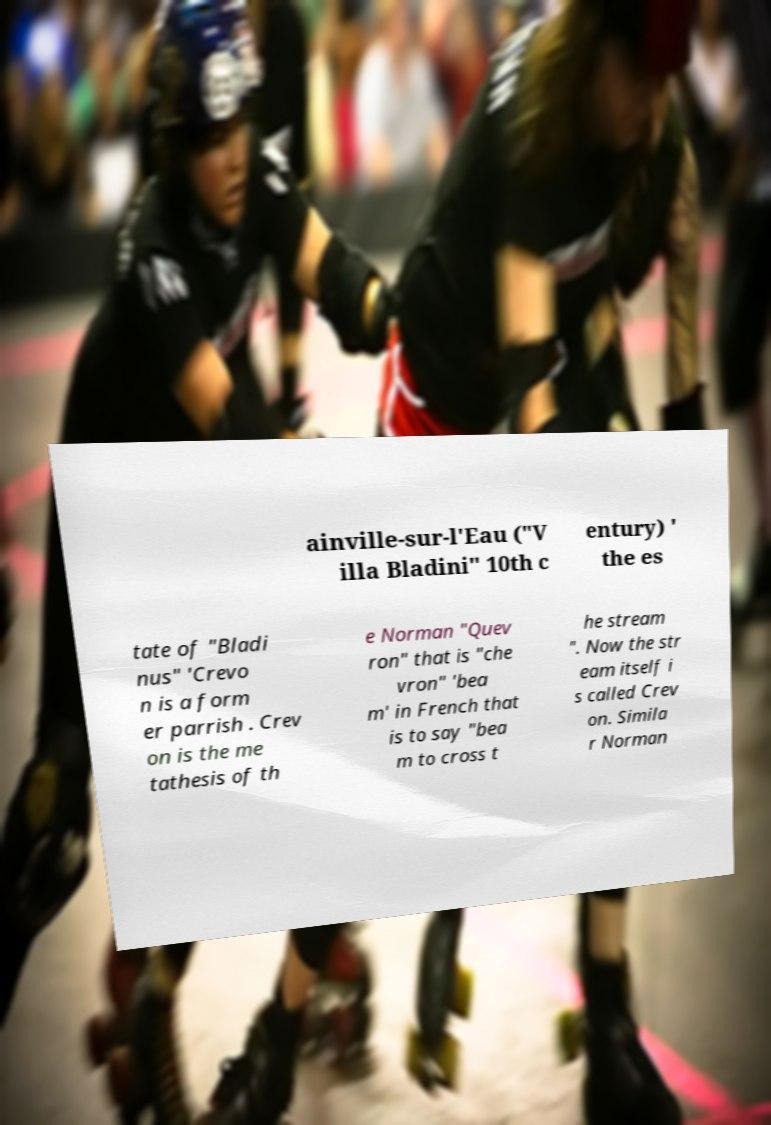What messages or text are displayed in this image? I need them in a readable, typed format. ainville-sur-l'Eau ("V illa Bladini" 10th c entury) ' the es tate of "Bladi nus" 'Crevo n is a form er parrish . Crev on is the me tathesis of th e Norman "Quev ron" that is "che vron" 'bea m' in French that is to say "bea m to cross t he stream ". Now the str eam itself i s called Crev on. Simila r Norman 